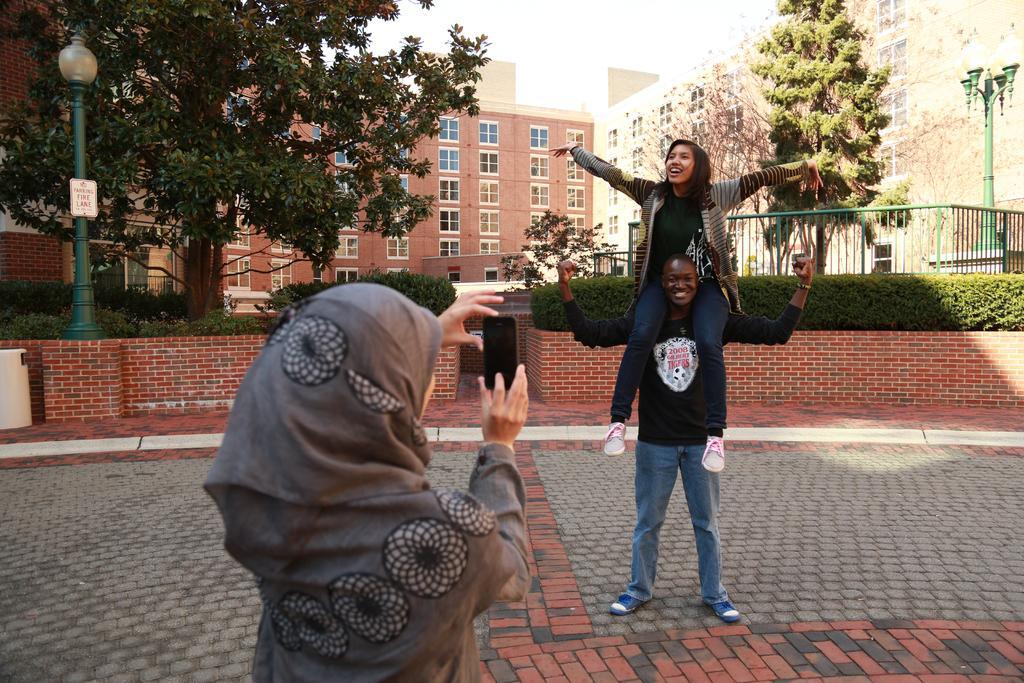Could you give a brief overview of what you see in this image? A man is carrying a woman, here a woman is holding phone, here there are buildings and trees. 